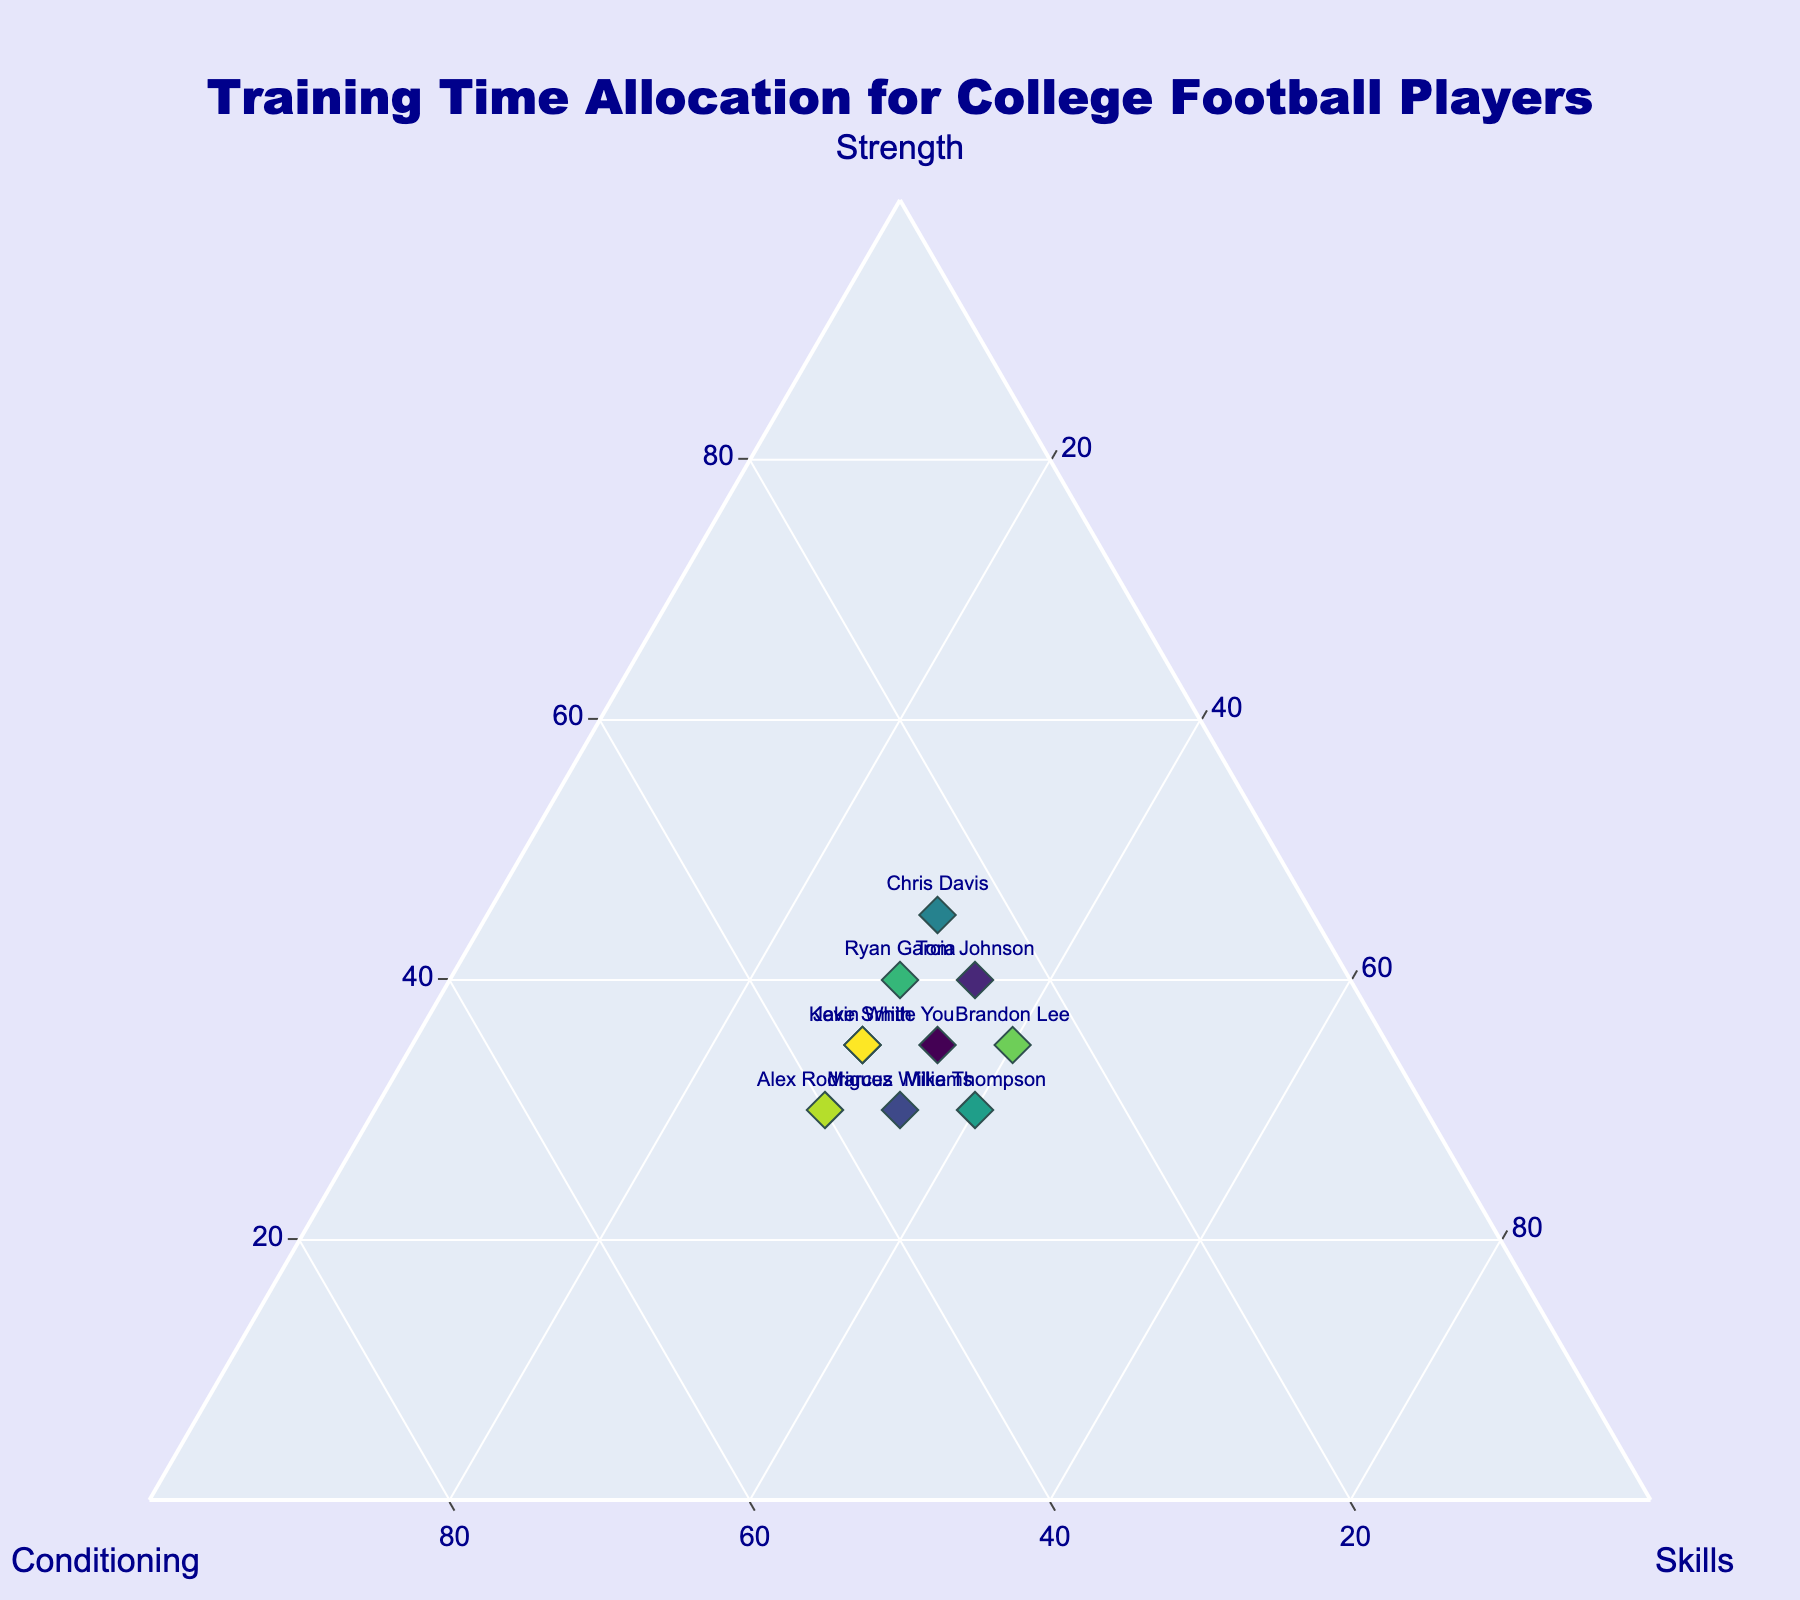What is the title of the plot? The title of the plot is located at the top of the figure.
Answer: Training Time Allocation for College Football Players How many data points are plotted in the ternary plot? By counting the markers present in the ternary plot, we can determine the number of data points.
Answer: 10 Which player allocates the most time to Strength training? By locating the marker closest to the 'Strength' axis with the highest value, we can find the answer.
Answer: Chris Davis Which player balances their training time equally in Conditioning and Skills? Locate the marker that has equal or nearly equal values in both Conditioning and Skills.
Answer: Marcus Williams and Alex Rodriguez What is the average conditioning time for all players? Summing up the conditioning times for all players (30, 25, 35, 35, 25, 30, 30, 25, 40, 35), we get 310. Dividing by the total number of players (10) gives the average.
Answer: 31 Who spends the least time on Skills training? By finding the marker closest to the 'Skills' axis with the lowest value, we get the answer.
Answer: Chris Davis What is the total time allocation for Strength and Skills for Tom Johnson? Adding up Strength (40) and Skills (35) for Tom Johnson yields the total time.
Answer: 75 Which player allocates an equal amount of time in Strength and Skills? By locating the marker that has equal values for both Strength and Skills, we find the answer.
Answer: Mike Thompson and Brandon Lee What's the difference in Conditioning time between Alex Rodriguez and Jake Smith? Subtract the Conditioning time of Jake Smith (35) from Alex Rodriguez (40) to find the difference.
Answer: 5 Who spends the most balanced time across all the three training categories? The player with markers closest to the center of the ternary plot spends balanced time across all three categories.
Answer: Kevin White 